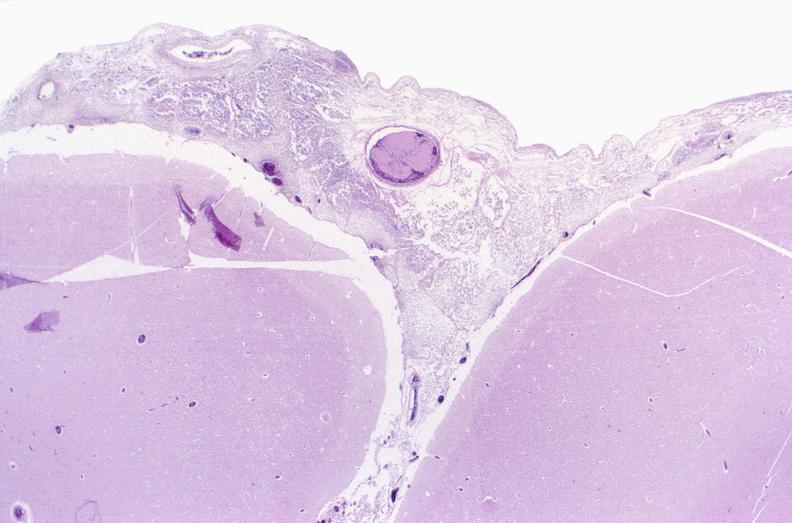s nervous present?
Answer the question using a single word or phrase. Yes 